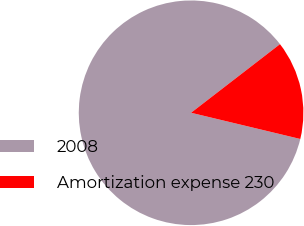Convert chart to OTSL. <chart><loc_0><loc_0><loc_500><loc_500><pie_chart><fcel>2008<fcel>Amortization expense 230<nl><fcel>85.79%<fcel>14.21%<nl></chart> 